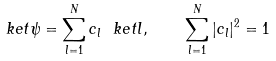Convert formula to latex. <formula><loc_0><loc_0><loc_500><loc_500>\ k e t { \psi } = \sum _ { l = 1 } ^ { N } c _ { l } \ k e t { l } , \quad \sum _ { l = 1 } ^ { N } | c _ { l } | ^ { 2 } = 1</formula> 